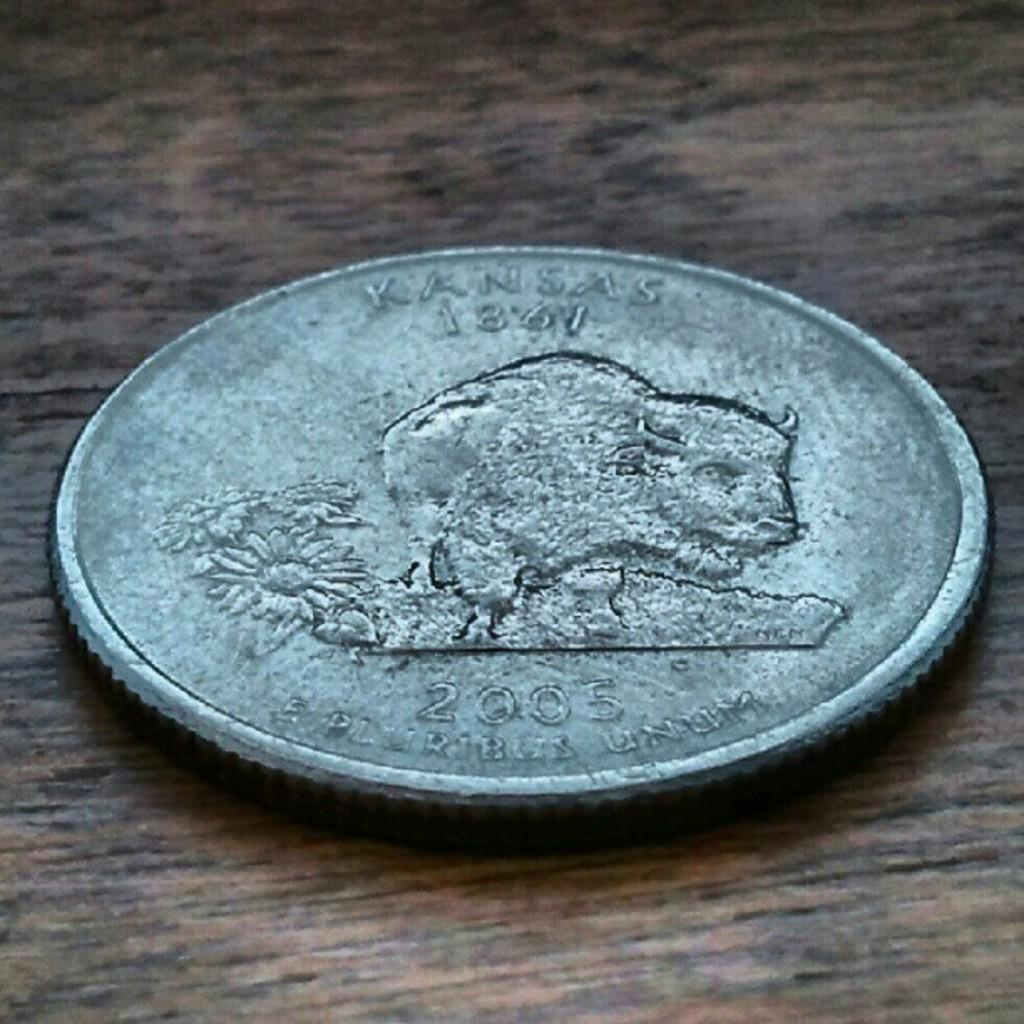<image>
Summarize the visual content of the image. a tarnished silver coin with the word Kansas on the top 